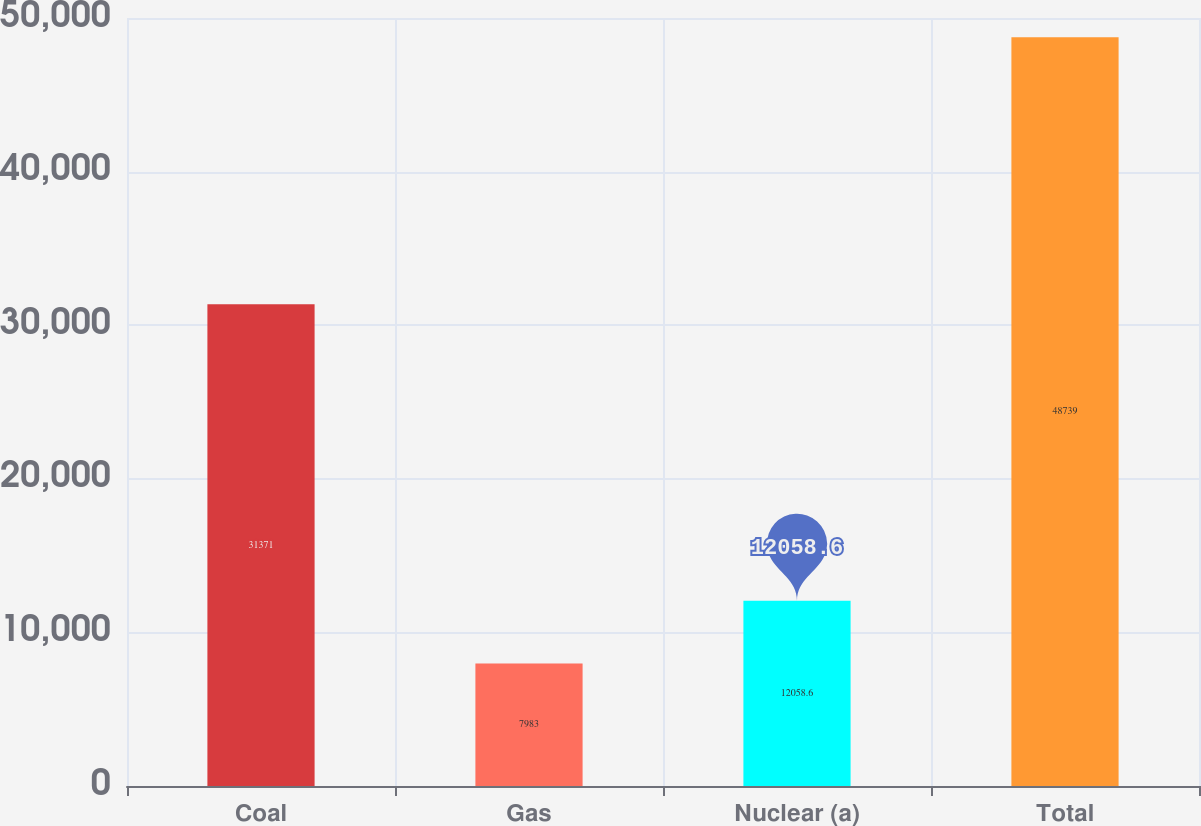Convert chart. <chart><loc_0><loc_0><loc_500><loc_500><bar_chart><fcel>Coal<fcel>Gas<fcel>Nuclear (a)<fcel>Total<nl><fcel>31371<fcel>7983<fcel>12058.6<fcel>48739<nl></chart> 